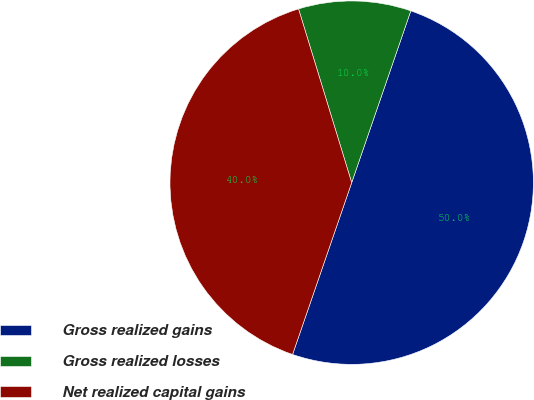Convert chart to OTSL. <chart><loc_0><loc_0><loc_500><loc_500><pie_chart><fcel>Gross realized gains<fcel>Gross realized losses<fcel>Net realized capital gains<nl><fcel>50.0%<fcel>10.0%<fcel>40.0%<nl></chart> 